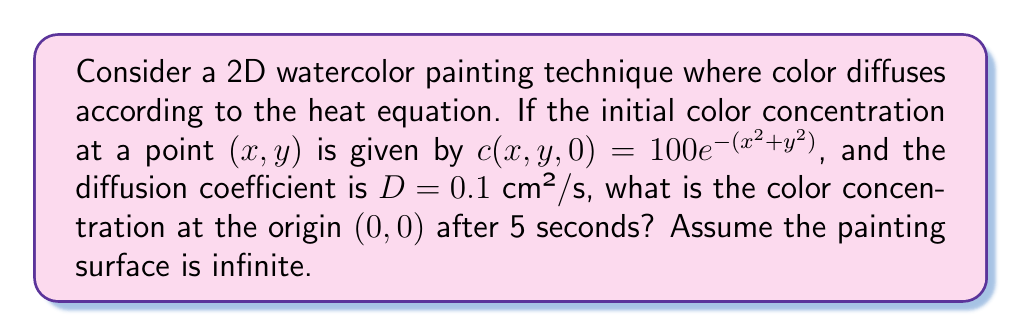Help me with this question. To solve this problem, we'll use the 2D heat equation solution for an infinite domain:

1) The general solution for the 2D heat equation is:
   $$c(x,y,t) = \frac{1}{4\pi Dt} \int_{-\infty}^{\infty} \int_{-\infty}^{\infty} c(x',y',0) e^{-\frac{(x-x')^2+(y-y')^2}{4Dt}} dx'dy'$$

2) Our initial condition is $c(x,y,0) = 100e^{-(x^2+y^2)}$

3) We want to find $c(0,0,5)$, so we substitute $x=0$, $y=0$, $t=5$, and $D=0.1$:
   $$c(0,0,5) = \frac{1}{4\pi(0.1)(5)} \int_{-\infty}^{\infty} \int_{-\infty}^{\infty} 100e^{-(x'^2+y'^2)} e^{-\frac{x'^2+y'^2}{4(0.1)(5)}} dx'dy'$$

4) Simplify the constant term:
   $$c(0,0,5) = \frac{100}{2\pi} \int_{-\infty}^{\infty} \int_{-\infty}^{\infty} e^{-(x'^2+y'^2)} e^{-\frac{x'^2+y'^2}{2}} dx'dy'$$

5) Combine the exponents:
   $$c(0,0,5) = \frac{100}{2\pi} \int_{-\infty}^{\infty} \int_{-\infty}^{\infty} e^{-\frac{3}{2}(x'^2+y'^2)} dx'dy'$$

6) This integral can be separated and solved using the Gaussian integral formula:
   $$c(0,0,5) = \frac{100}{2\pi} \left(\sqrt{\frac{2\pi}{3}}\right)^2 = \frac{100}{3}$$

Therefore, the color concentration at the origin after 5 seconds is $\frac{100}{3}$.
Answer: $\frac{100}{3}$ 